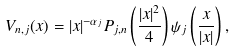Convert formula to latex. <formula><loc_0><loc_0><loc_500><loc_500>V _ { n , j } ( x ) = | x | ^ { - \alpha _ { j } } P _ { j , n } \left ( \frac { | x | ^ { 2 } } { 4 } \right ) \psi _ { j } \left ( \frac { x } { | x | } \right ) ,</formula> 